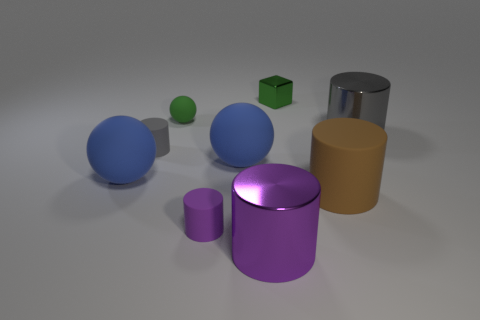Subtract all gray matte cylinders. How many cylinders are left? 4 Subtract all brown cylinders. How many cylinders are left? 4 Subtract all blue cylinders. Subtract all green spheres. How many cylinders are left? 5 Subtract all blocks. How many objects are left? 8 Add 7 big purple objects. How many big purple objects are left? 8 Add 4 large green blocks. How many large green blocks exist? 4 Subtract 0 green cylinders. How many objects are left? 9 Subtract all gray rubber spheres. Subtract all cubes. How many objects are left? 8 